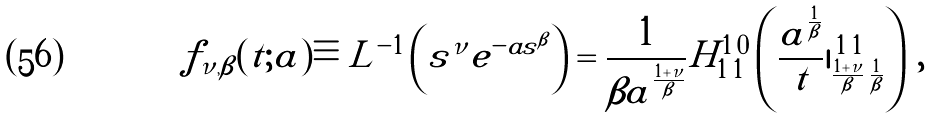<formula> <loc_0><loc_0><loc_500><loc_500>f _ { \nu , \beta } ( t ; a ) \equiv L ^ { - 1 } \left ( s ^ { \nu } e ^ { - a s ^ { \beta } } \right ) = \frac { 1 } { \beta a ^ { \frac { 1 + \nu } { \beta } } } H _ { 1 \, 1 } ^ { 1 \, 0 } \left ( \frac { a ^ { \frac { 1 } { \beta } } } { t } | ^ { \, 1 \, 1 } _ { \frac { 1 + \nu } { \beta } \, \frac { 1 } { \beta } } \right ) \, ,</formula> 